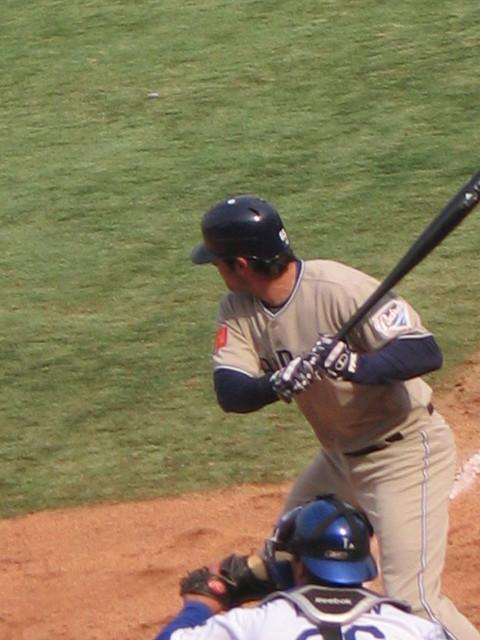What action is the man wearing blue hat doing? catching 